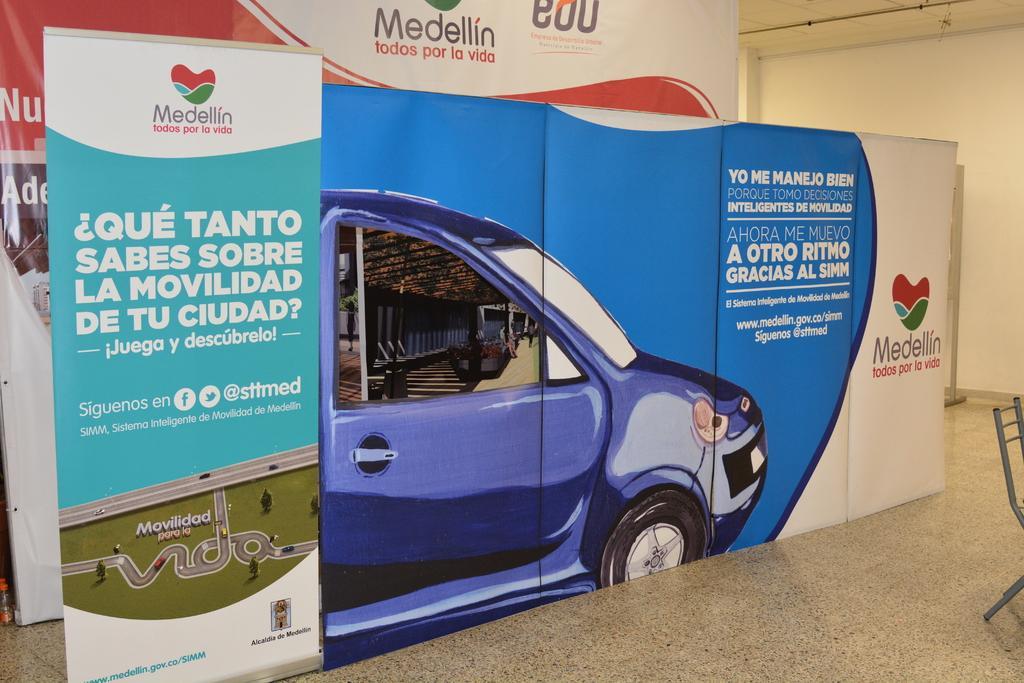Please provide a concise description of this image. In this picture we can see few hoardings, a chair and a wall. 